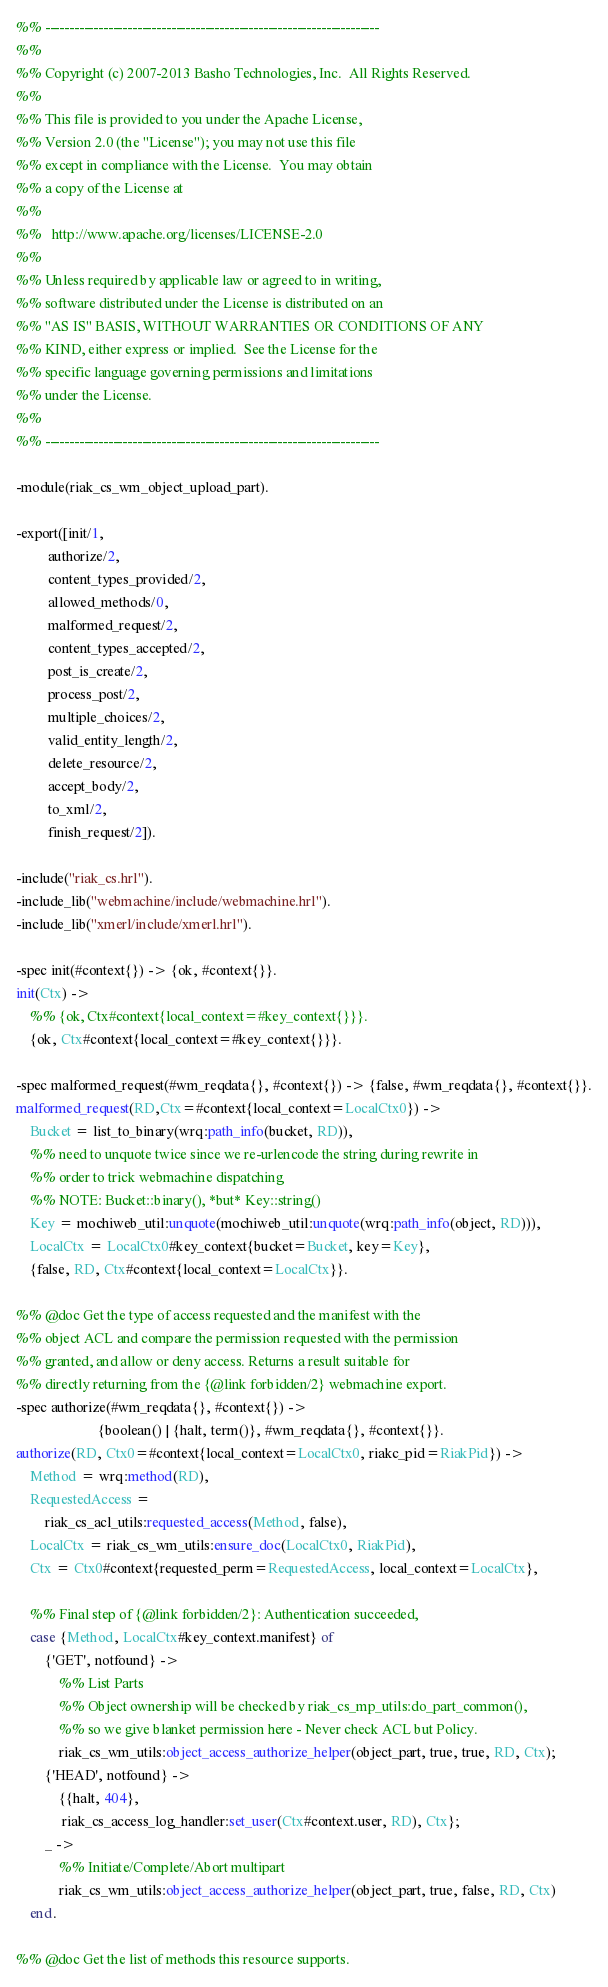Convert code to text. <code><loc_0><loc_0><loc_500><loc_500><_Erlang_>%% ---------------------------------------------------------------------
%%
%% Copyright (c) 2007-2013 Basho Technologies, Inc.  All Rights Reserved.
%%
%% This file is provided to you under the Apache License,
%% Version 2.0 (the "License"); you may not use this file
%% except in compliance with the License.  You may obtain
%% a copy of the License at
%%
%%   http://www.apache.org/licenses/LICENSE-2.0
%%
%% Unless required by applicable law or agreed to in writing,
%% software distributed under the License is distributed on an
%% "AS IS" BASIS, WITHOUT WARRANTIES OR CONDITIONS OF ANY
%% KIND, either express or implied.  See the License for the
%% specific language governing permissions and limitations
%% under the License.
%%
%% ---------------------------------------------------------------------

-module(riak_cs_wm_object_upload_part).

-export([init/1,
         authorize/2,
         content_types_provided/2,
         allowed_methods/0,
         malformed_request/2,
         content_types_accepted/2,
         post_is_create/2,
         process_post/2,
         multiple_choices/2,
         valid_entity_length/2,
         delete_resource/2,
         accept_body/2,
         to_xml/2,
         finish_request/2]).

-include("riak_cs.hrl").
-include_lib("webmachine/include/webmachine.hrl").
-include_lib("xmerl/include/xmerl.hrl").

-spec init(#context{}) -> {ok, #context{}}.
init(Ctx) ->
    %% {ok, Ctx#context{local_context=#key_context{}}}.
    {ok, Ctx#context{local_context=#key_context{}}}.

-spec malformed_request(#wm_reqdata{}, #context{}) -> {false, #wm_reqdata{}, #context{}}.
malformed_request(RD,Ctx=#context{local_context=LocalCtx0}) ->
    Bucket = list_to_binary(wrq:path_info(bucket, RD)),
    %% need to unquote twice since we re-urlencode the string during rewrite in
    %% order to trick webmachine dispatching
    %% NOTE: Bucket::binary(), *but* Key::string()
    Key = mochiweb_util:unquote(mochiweb_util:unquote(wrq:path_info(object, RD))),
    LocalCtx = LocalCtx0#key_context{bucket=Bucket, key=Key},
    {false, RD, Ctx#context{local_context=LocalCtx}}.

%% @doc Get the type of access requested and the manifest with the
%% object ACL and compare the permission requested with the permission
%% granted, and allow or deny access. Returns a result suitable for
%% directly returning from the {@link forbidden/2} webmachine export.
-spec authorize(#wm_reqdata{}, #context{}) ->
                       {boolean() | {halt, term()}, #wm_reqdata{}, #context{}}.
authorize(RD, Ctx0=#context{local_context=LocalCtx0, riakc_pid=RiakPid}) ->
    Method = wrq:method(RD),
    RequestedAccess =
        riak_cs_acl_utils:requested_access(Method, false),
    LocalCtx = riak_cs_wm_utils:ensure_doc(LocalCtx0, RiakPid),
    Ctx = Ctx0#context{requested_perm=RequestedAccess, local_context=LocalCtx},

    %% Final step of {@link forbidden/2}: Authentication succeeded,
    case {Method, LocalCtx#key_context.manifest} of
        {'GET', notfound} ->
            %% List Parts
            %% Object ownership will be checked by riak_cs_mp_utils:do_part_common(),
            %% so we give blanket permission here - Never check ACL but Policy.
            riak_cs_wm_utils:object_access_authorize_helper(object_part, true, true, RD, Ctx);
        {'HEAD', notfound} ->
            {{halt, 404},
             riak_cs_access_log_handler:set_user(Ctx#context.user, RD), Ctx};
        _ ->
            %% Initiate/Complete/Abort multipart
            riak_cs_wm_utils:object_access_authorize_helper(object_part, true, false, RD, Ctx)
    end.

%% @doc Get the list of methods this resource supports.</code> 